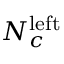Convert formula to latex. <formula><loc_0><loc_0><loc_500><loc_500>N _ { c } ^ { l e f t }</formula> 